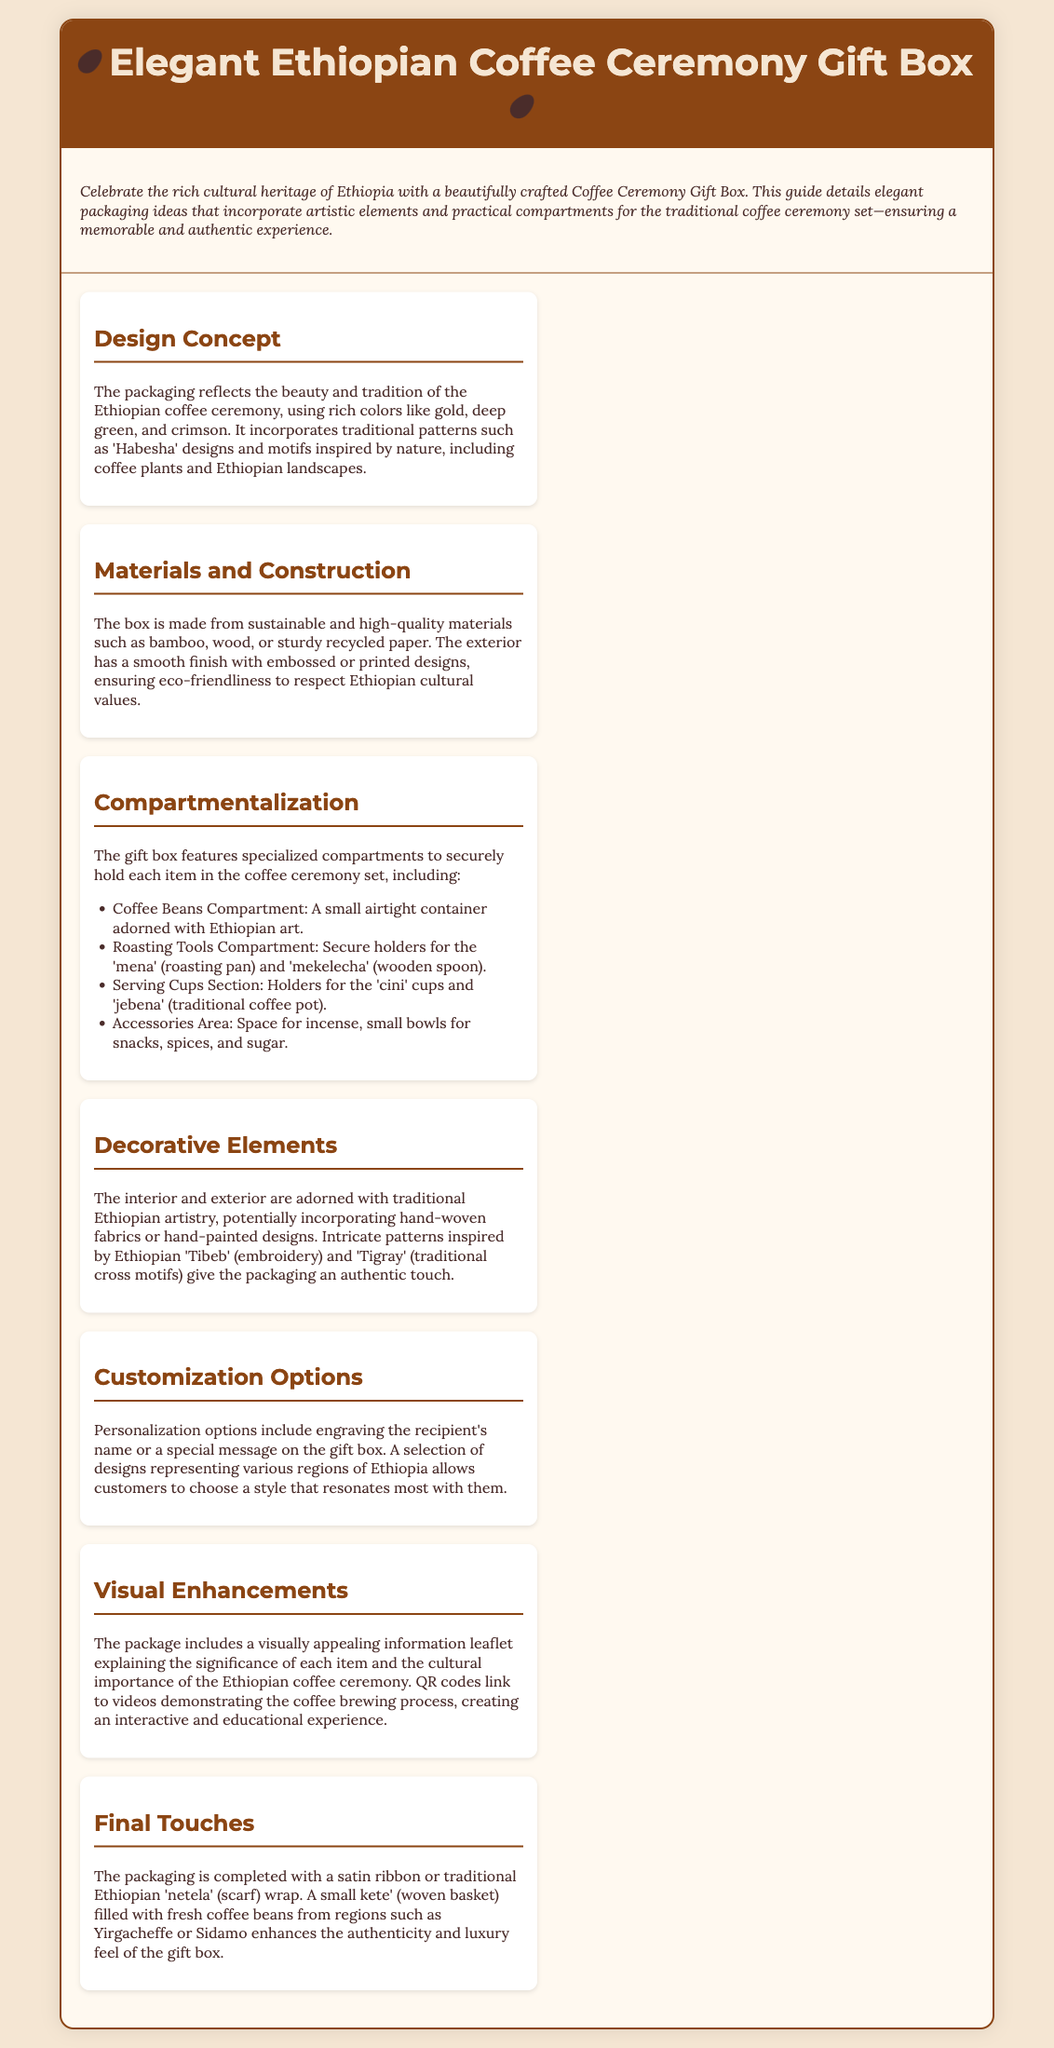What is the primary material used for the gift box? The document mentions that the box is made from sustainable and high-quality materials such as bamboo, wood, or sturdy recycled paper.
Answer: bamboo, wood, recycled paper What is a unique feature of the Coffee Beans Compartment? The Coffee Beans Compartment includes a small airtight container adorned with Ethiopian art.
Answer: airtight container adorned with Ethiopian art What traditional items are securely held in the Roasting Tools Compartment? The document lists holders for the 'mena' (roasting pan) and 'mekelecha' (wooden spoon) as being included in this compartment.
Answer: 'mena' and 'mekelecha' Which decorative elements are mentioned in the packaging design? The document states that the interior and exterior are adorned with hand-woven fabrics or hand-painted designs.
Answer: hand-woven fabrics and hand-painted designs What additional personalization option is offered for the gift box? The document highlights the option to engrave the recipient's name or a special message on the gift box.
Answer: engraving What type of visual enhancement is included in the package? The package includes a visually appealing information leaflet explaining the significance of each item.
Answer: information leaflet What final touch is mentioned to enhance the luxury feel of the gift box? The document states that a small kete' (woven basket) filled with fresh coffee beans enhances the authenticity and luxury feel.
Answer: kete' filled with fresh coffee beans 